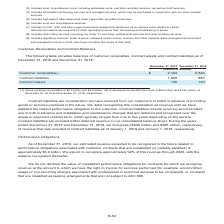According to Centurylink's financial document, What was the gross customer receivables at December 31, 2019? According to the financial document, $2.3 billion. The relevant text states: "(1) Gross customer receivables of $2.3 billion and $2.5 billion, net of allowance for doubtful accounts of $94 million and $132 million, at Decembe..." Also, What do contract liabilities include? recurring services billed one month in advance and installation and maintenance charges that are deferred and recognized over the actual or expected contract term, which typically ranges from one to five years depending on the service. The document states: "ion to the customer. Contract liabilities include recurring services billed one month in advance and installation and maintenance charges that are def..." Also, What are the items analyzed in the table? The document contains multiple relevant values: Customer receivables, Contract liabilities, Contract assets. From the document: ". $ 2,194 2,346 Contract liabilities . 1,028 860 Contract assets . 130 140 illions) Customer receivables (1) . $ 2,194 2,346 Contract liabilities . 1,..." Also, can you calculate: What is the change in net of allowance for doubtful accounts in 2019 from 2018? Based on the calculation: $94-$132, the result is -38 (in millions). This is based on the information: "lars in millions) Customer receivables (1) . $ 2,194 2,346 Contract liabilities . 1,028 860 Contract assets . 130 140 lowance for doubtful accounts of $94 million and $132 million, at December 31, 201..." The key data points involved are: 132, 94. Also, can you calculate: What is the change in contract liabilities in 2019 from 2018? Based on the calculation: $1,028-$860, the result is 168 (in millions). This is based on the information: "(1) . $ 2,194 2,346 Contract liabilities . 1,028 860 Contract assets . 130 140 vables (1) . $ 2,194 2,346 Contract liabilities . 1,028 860 Contract assets . 130 140..." The key data points involved are: 1,028, 860. Also, can you calculate: What is the average amount of contract assets for 2018 and 2019? To answer this question, I need to perform calculations using the financial data. The calculation is: ($130+$140)/2, which equals 135 (in millions). This is based on the information: "ontract liabilities . 1,028 860 Contract assets . 130 140 act liabilities . 1,028 860 Contract assets . 130 140..." The key data points involved are: 130, 140. 